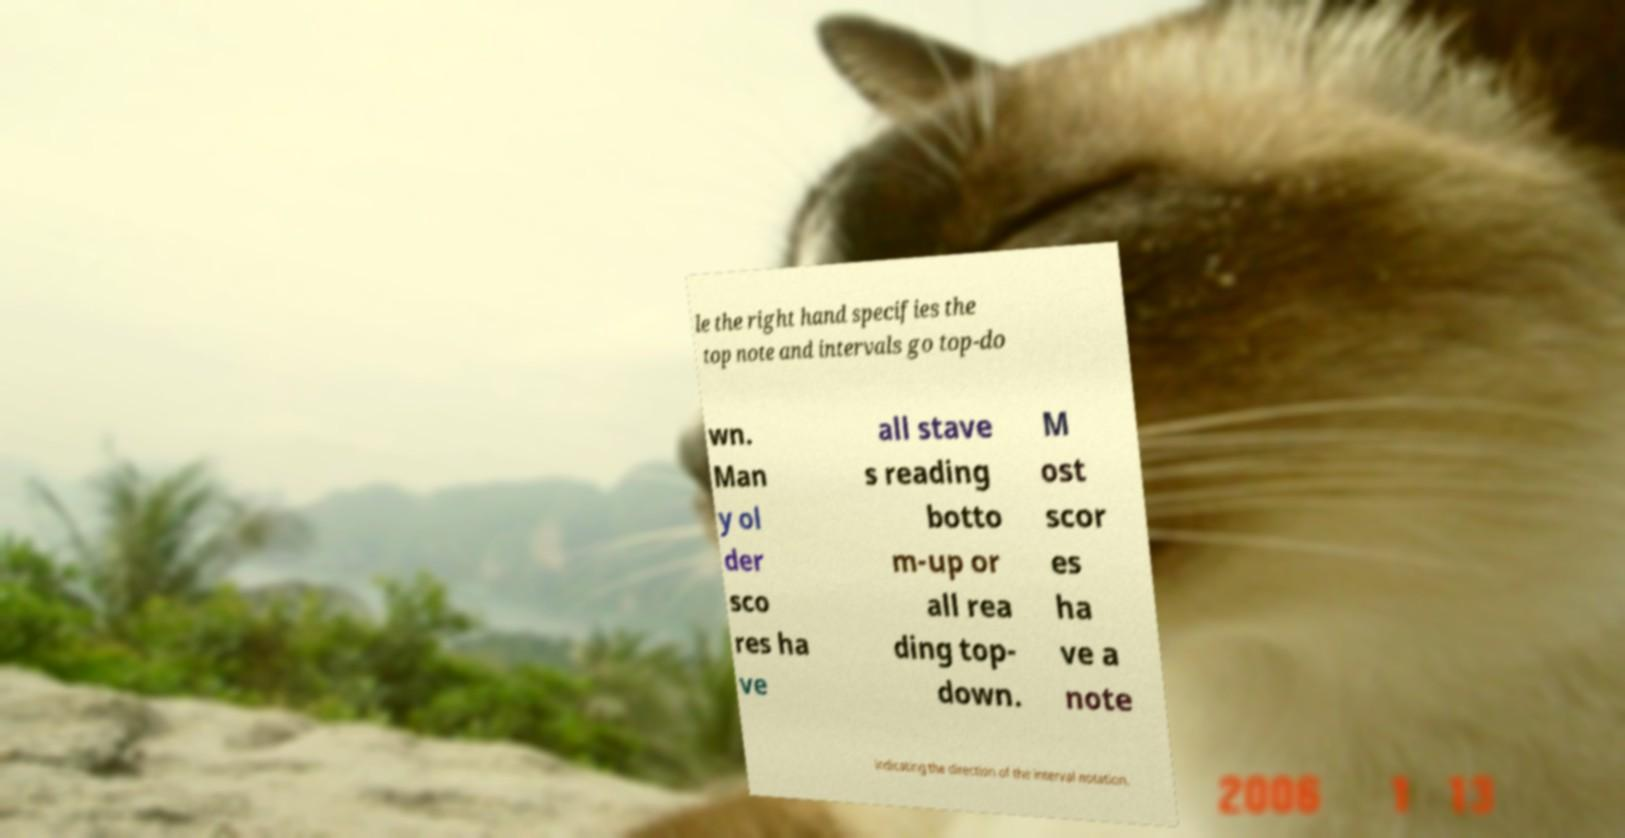Can you read and provide the text displayed in the image?This photo seems to have some interesting text. Can you extract and type it out for me? le the right hand specifies the top note and intervals go top-do wn. Man y ol der sco res ha ve all stave s reading botto m-up or all rea ding top- down. M ost scor es ha ve a note indicating the direction of the interval notation. 